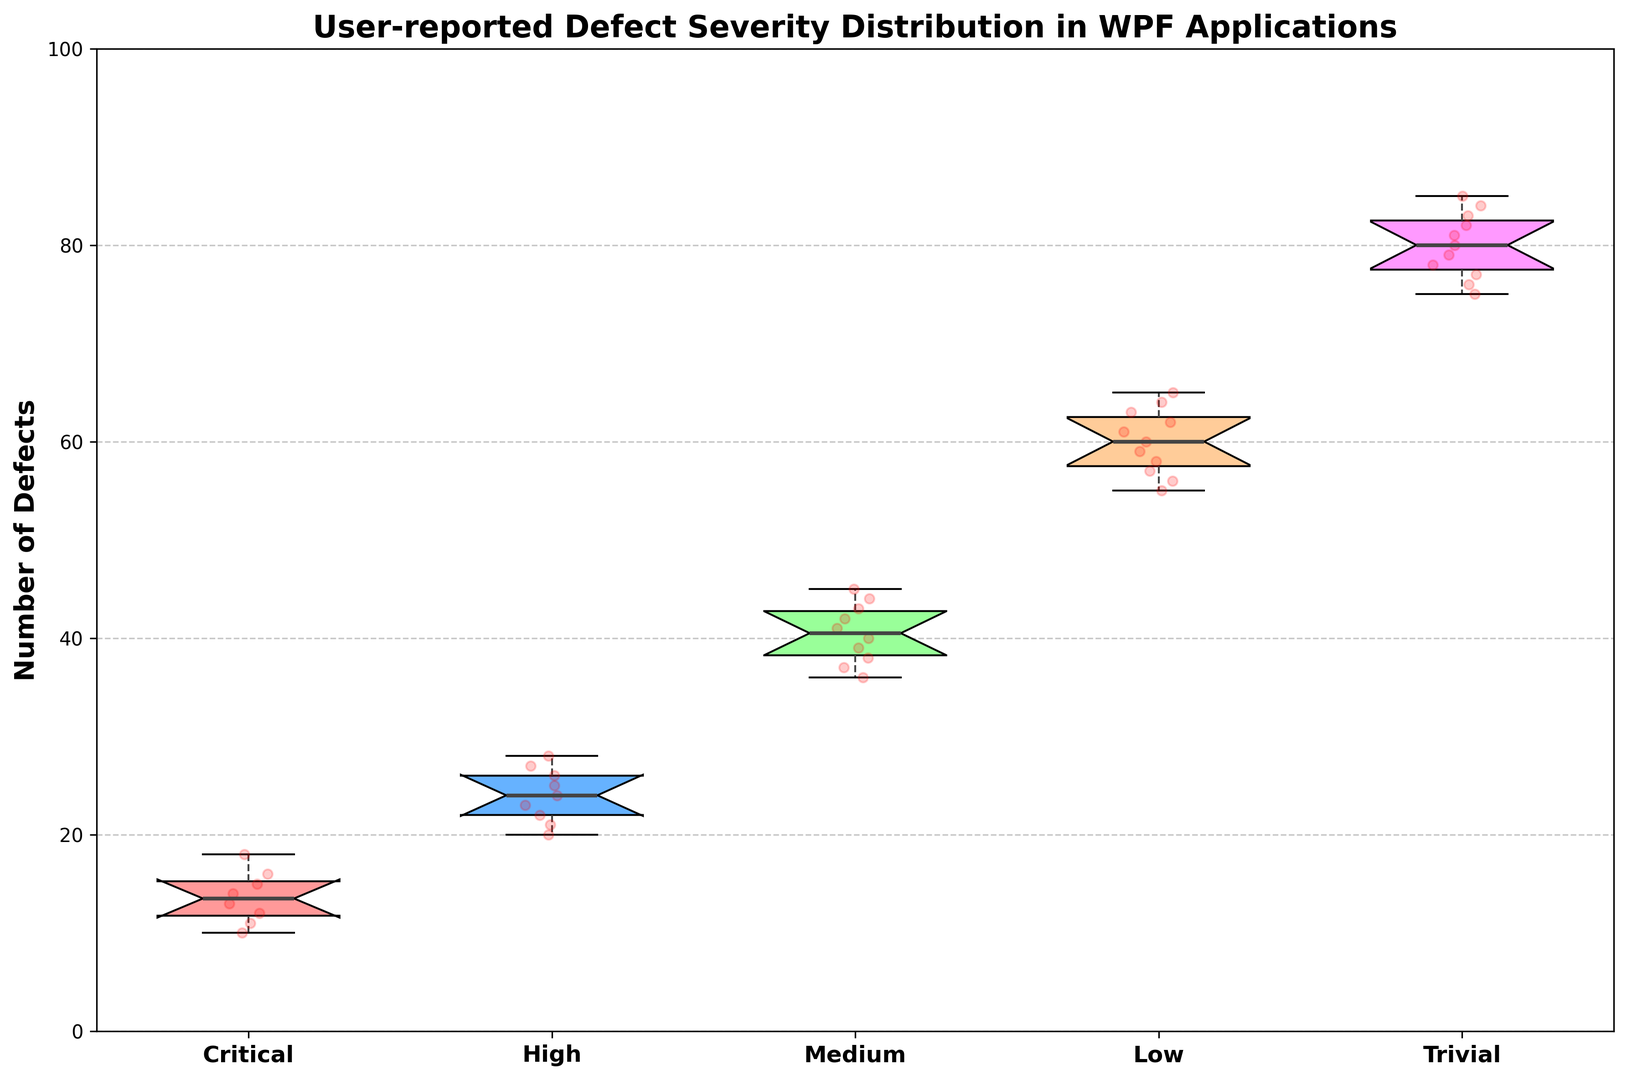What's the median number of defects for the "High" severity category? Find the "High" box plot, locate the median line within the box which represents the median number of defects. The median line within the box for "High" severity is at 24.
Answer: 24 Which severity category has the widest range of defect counts? The range of the data is indicated by the distance between the top and bottom whiskers of each box plot. The "Trivial" category has the most spread-out whiskers, indicating a wider range of defect counts.
Answer: Trivial Compare the interquartile ranges (IQRs) of the "Critical" and "Medium" categories. The IQR is the length of the box in the box plot. For "Critical", the IQR spans from approximately 12 to 16. For "Medium", the IQR spans from approximately 37 to 43. To compare accurately, we subtract the lower quartile from the upper quartile for each category: 
"Critical" IQR: 16 - 12 = 4
"Medium" IQR: 43 - 37 = 6
Answer: Medium has a larger IQR than Critical In which severity category do the data points show the highest clustering near the median? Clustering around the median can be determined by how closely the data points are plotted around the box plot's median line. In the "Critical" category, data points are very close to the median value of 13.
Answer: Critical Is the range of defect counts for the "Low" category greater than for the "High" category? Compare the whisker lengths: "Low" spans from 55 to 65 (range = 65 - 55 = 10), and "High" spans from 20 to 28 (range = 28 - 20 = 8).
Answer: Yes Between "Medium" and "Low" severities, which category has a higher maximum and by how much? Identify the top whisker of both box plots: "Medium" has a maximum defect count of 45, and "Low" has a maximum defect count of 65. The difference is calculated as 65 - 45 = 20.
Answer: Low by 20 What is the minimum number of defects for the "Trivial" category and how does this compare to the minimum for the "High" category? The minimum number of defects is found at the bottom whisker. For "Trivial", the minimum is 75. For "High", the minimum is 20. Therefore, the "Trivial" category's minimum is higher by 75 - 20 = 55 than the "High" category's minimum.
Answer: Trivial is 55 more than High Are there any outliers in the "Low" severity category? Outliers are typically indicated by dots outside the whiskers. For the "Low" category, no data points are plotted outside the whiskers, indicating no outliers.
Answer: No How does the spread of defect counts for "Critical" compare to "Trivial"? Determine the range for both categories: "Critical" spans from 10 to 18, having a range of 18 - 10 = 8. "Trivial" spans from 75 to 85, with a range of 85 - 75 = 10. The "Trivial" category has a slightly larger spread.
Answer: Trivial has a larger spread In the "Medium" severity category, what proportion of defects fall between 37 and 43? In a box plot, the box itself represents the interquartile range (IQR). This range represents the middle 50% of the data. Since the IQR in the "Medium" category spans from 37 to 43, exactly 50% of the defects fall within this range.
Answer: 50% 